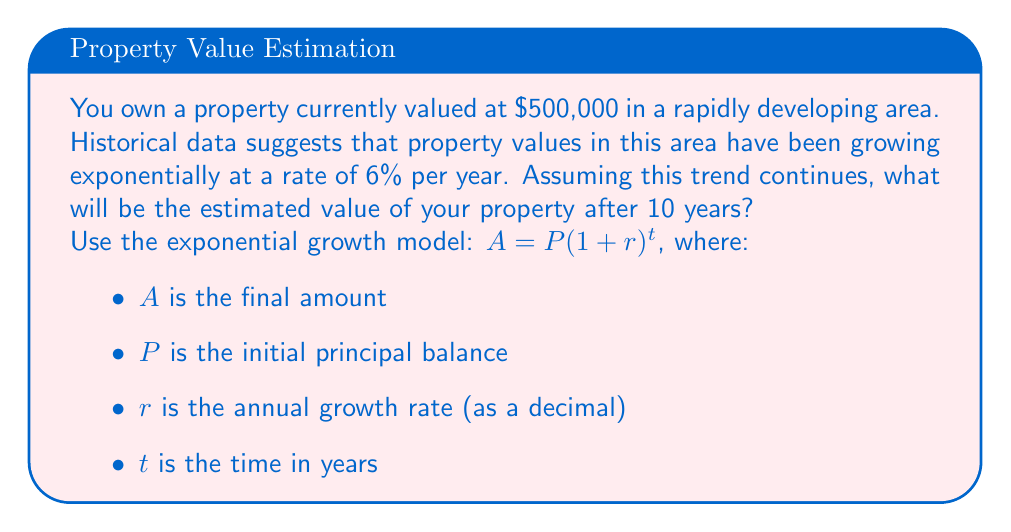Teach me how to tackle this problem. To solve this problem, we'll use the exponential growth model:

$A = P(1 + r)^t$

Where:
$P = 500,000$ (initial property value)
$r = 0.06$ (6% annual growth rate expressed as a decimal)
$t = 10$ years

Let's substitute these values into the equation:

$A = 500,000 (1 + 0.06)^{10}$

Now, let's solve this step-by-step:

1) First, calculate $(1 + 0.06)^{10}$:
   $(1.06)^{10} = 1.7908$

2) Multiply this result by the initial property value:
   $500,000 \times 1.7908 = 895,400$

Therefore, after 10 years, the estimated property value will be $895,400.

Note: In real-world scenarios, property values can be influenced by many factors beyond simple exponential growth. This model provides a basic estimate assuming consistent market conditions.
Answer: $895,400 